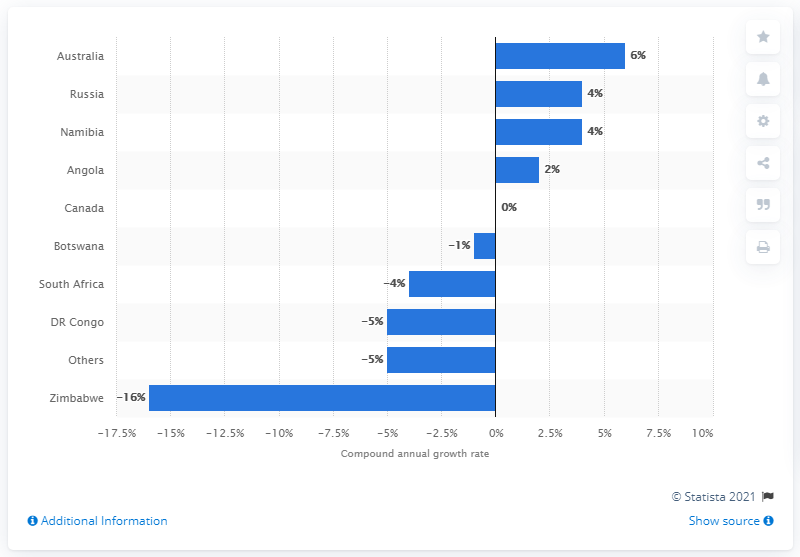Point out several critical features in this image. The compound annual growth rate for the top diamond-producing country worldwide between 2010 and 2015 was 4%. Australia and Angola, both being diamond-producing countries, differ in their compound annual growth rate for this period. Australia has the highest compound annual growth rate for the top diamonds worldwide between 2010 and 2015. 